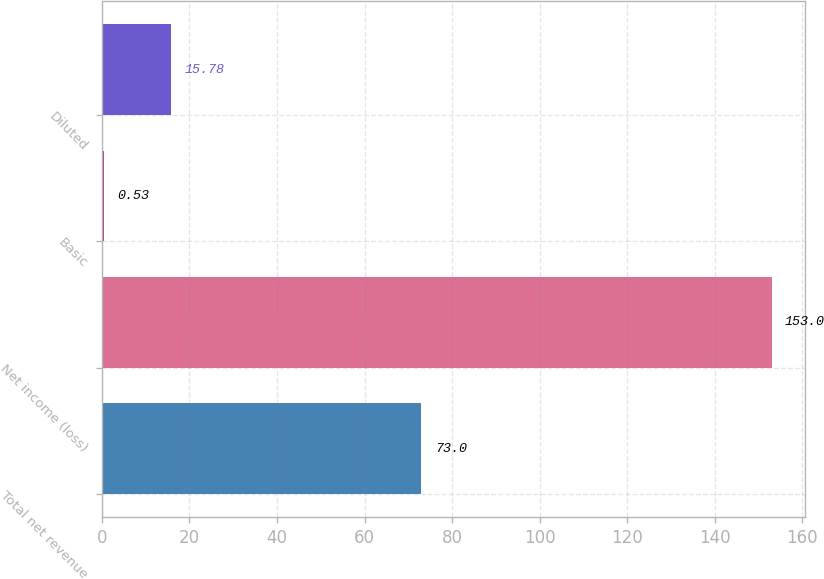Convert chart to OTSL. <chart><loc_0><loc_0><loc_500><loc_500><bar_chart><fcel>Total net revenue<fcel>Net income (loss)<fcel>Basic<fcel>Diluted<nl><fcel>73<fcel>153<fcel>0.53<fcel>15.78<nl></chart> 